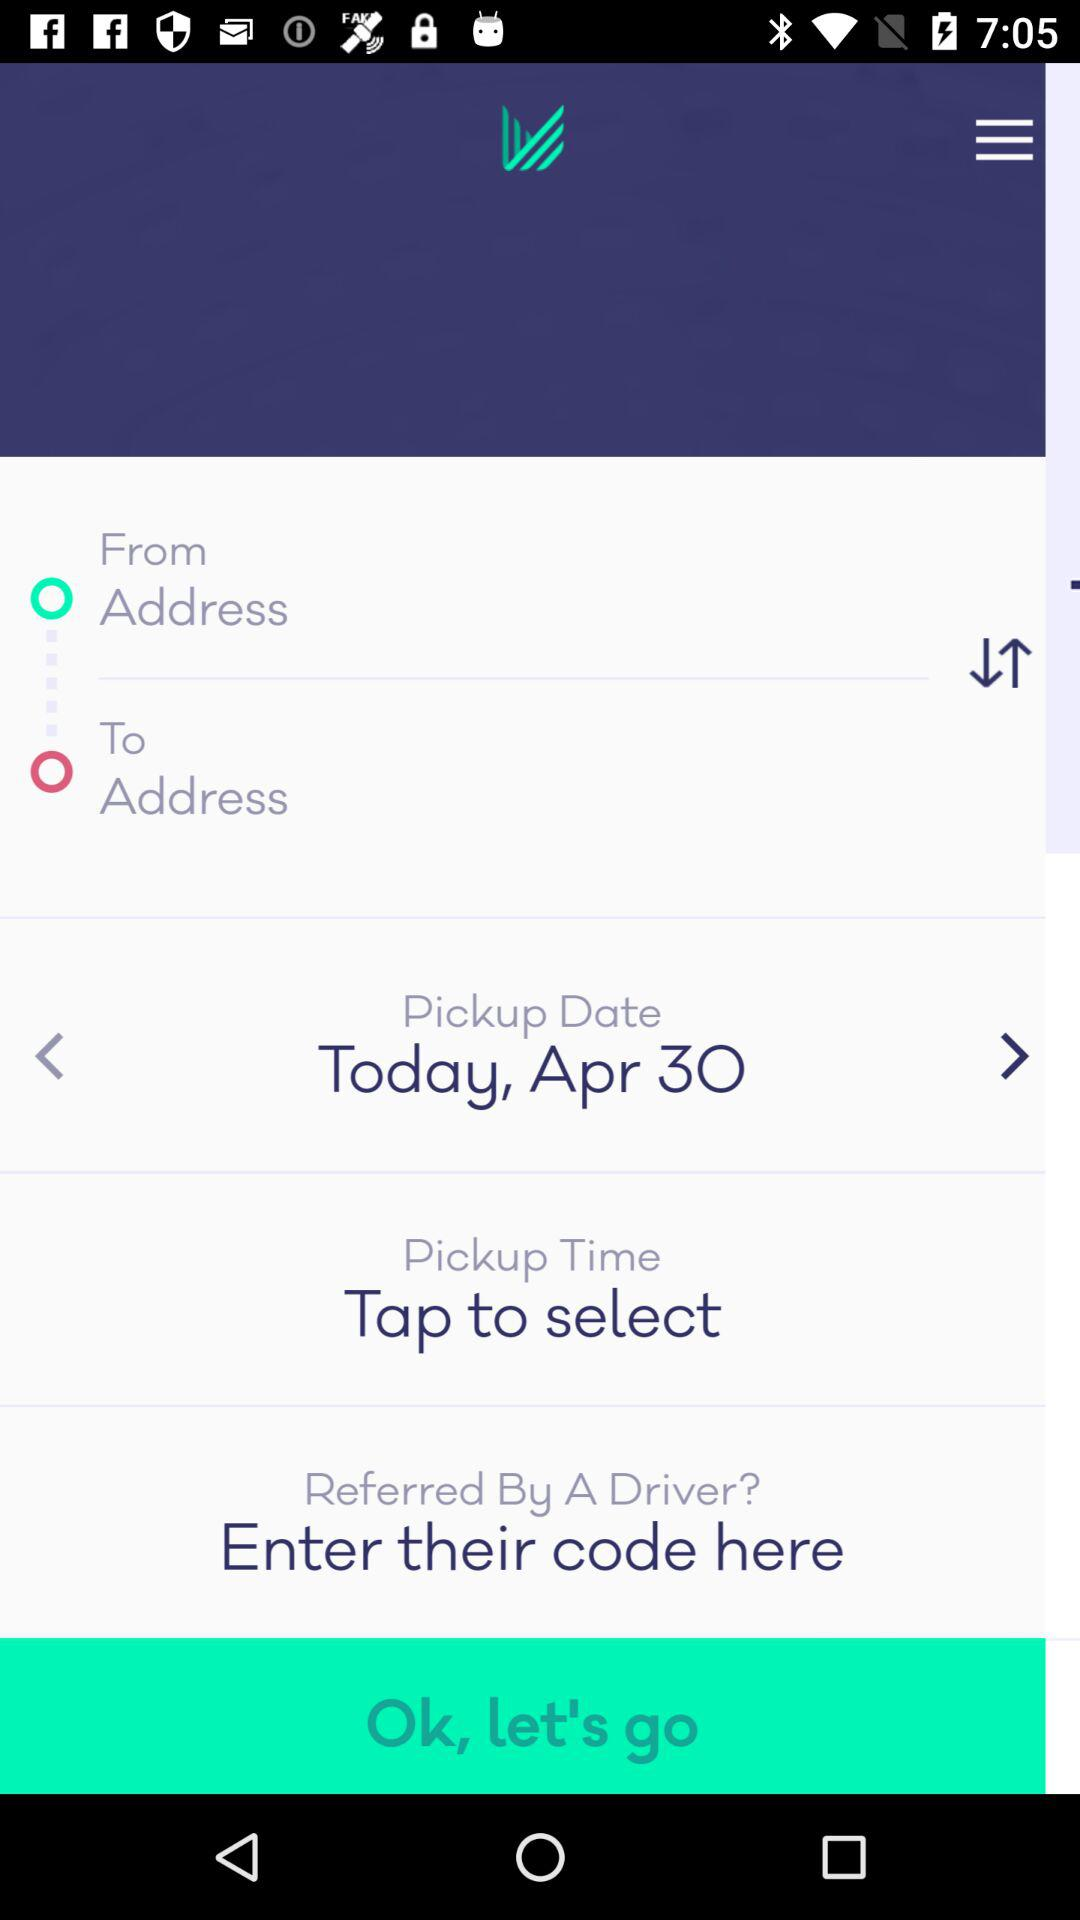What is the pickup date? The pickup date is today, April 30. 